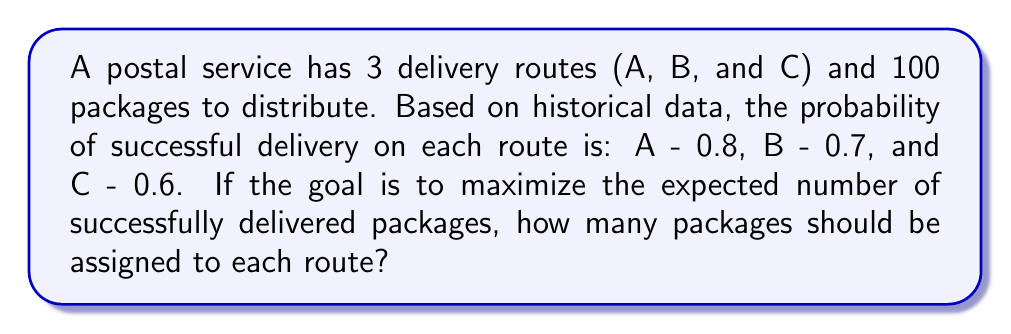Solve this math problem. To maximize the expected number of successfully delivered packages, we need to distribute the packages in proportion to the success probabilities of each route. Let's solve this step-by-step:

1) Let $x_A$, $x_B$, and $x_C$ be the number of packages assigned to routes A, B, and C respectively.

2) We know that the total number of packages is 100, so:

   $$x_A + x_B + x_C = 100$$

3) The expected number of successfully delivered packages for each route is:

   Route A: $0.8x_A$
   Route B: $0.7x_B$
   Route C: $0.6x_C$

4) To maximize efficiency, these expected values should be equal:

   $$0.8x_A = 0.7x_B = 0.6x_C$$

5) From this, we can derive:

   $$x_B = \frac{8}{7}x_A$$ and $$x_C = \frac{4}{3}x_A$$

6) Substituting these into the equation from step 2:

   $$x_A + \frac{8}{7}x_A + \frac{4}{3}x_A = 100$$

7) Simplifying:

   $$x_A(1 + \frac{8}{7} + \frac{4}{3}) = 100$$
   $$x_A(\frac{21}{21} + \frac{24}{21} + \frac{28}{21}) = 100$$
   $$x_A(\frac{73}{21}) = 100$$

8) Solving for $x_A$:

   $$x_A = \frac{2100}{73} \approx 28.77$$

9) Rounding to the nearest whole number (as we can't split packages):

   $$x_A = 29$$

10) Now we can calculate $x_B$ and $x_C$:

    $$x_B = \frac{8}{7}x_A = \frac{8}{7} * 29 \approx 33.14 \approx 33$$
    $$x_C = \frac{4}{3}x_A = \frac{4}{3} * 29 \approx 38.67 \approx 38$$

11) The total is 29 + 33 + 38 = 100, which matches our constraint.
Answer: Route A: 29 packages, Route B: 33 packages, Route C: 38 packages 